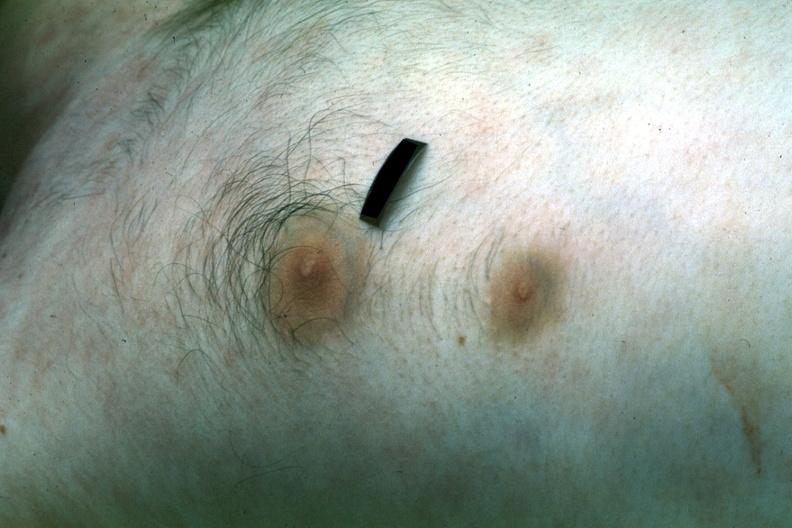where is this area in the body?
Answer the question using a single word or phrase. Breast 